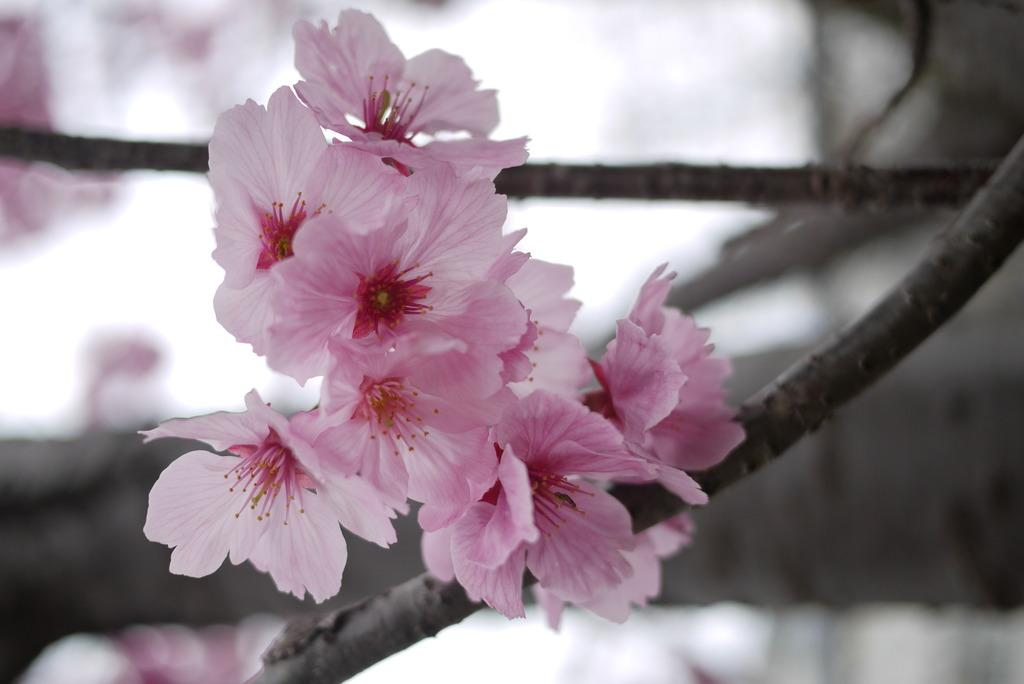What color are the flowers in the image? The flowers in the image are pink. Where are the flowers located? The flowers are on a tree. What can be observed about the tree in the image? The tree has branches. Can you describe the background of the image? The background of the image is blurred. What type of alley can be seen in the background of the image? There is no alley present in the image; the background is blurred. 